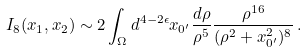<formula> <loc_0><loc_0><loc_500><loc_500>I _ { 8 } ( x _ { 1 } , x _ { 2 } ) \sim 2 \int _ { \Omega } d ^ { 4 - 2 \epsilon } x _ { 0 ^ { \prime } } \frac { d \rho } { \rho ^ { 5 } } \frac { \rho ^ { 1 6 } } { ( \rho ^ { 2 } + x _ { 0 ^ { \prime } } ^ { 2 } ) ^ { 8 } } \, .</formula> 